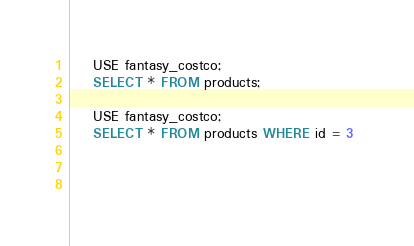<code> <loc_0><loc_0><loc_500><loc_500><_SQL_>
    USE fantasy_costco;
    SELECT * FROM products;

    USE fantasy_costco;
    SELECT * FROM products WHERE id = 3 


    </code> 